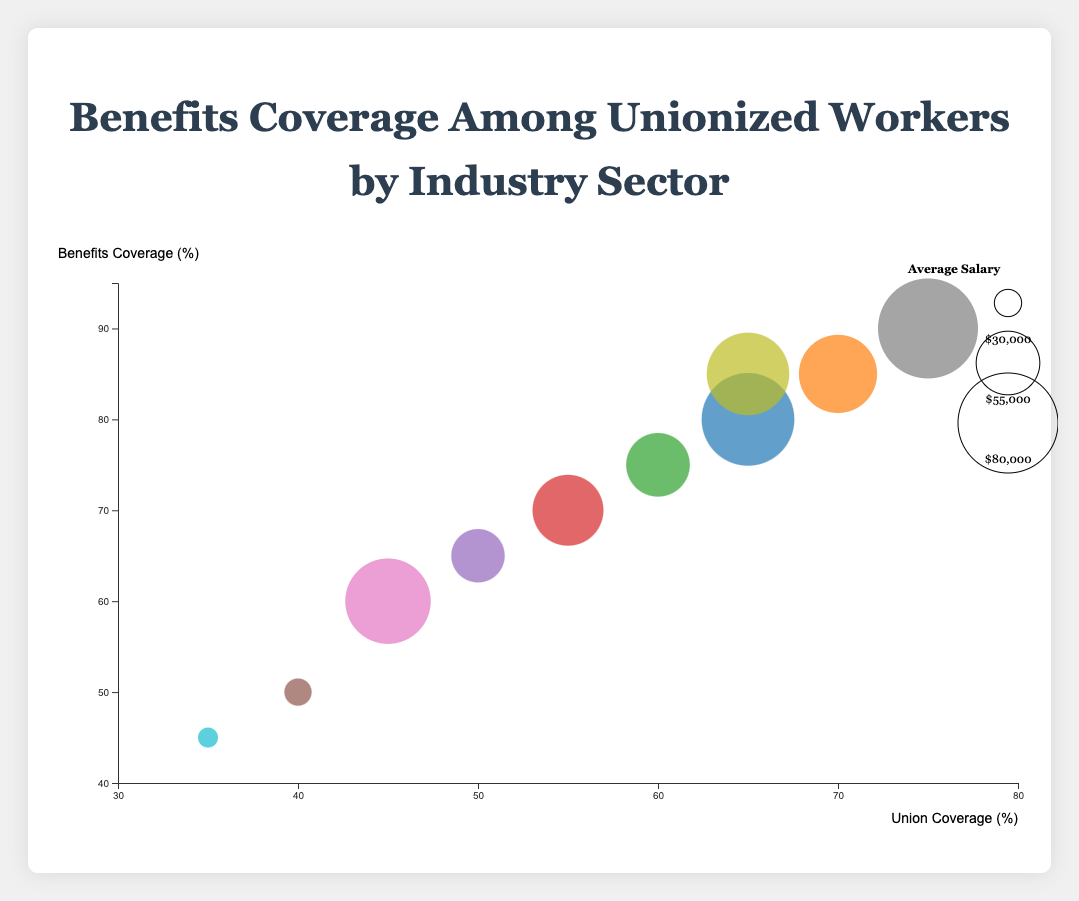What is the title of the chart? The title is usually placed at the top of the chart and provides a general description of the data being visualized. The title in bold, large text reads "Benefits Coverage Among Unionized Workers by Industry Sector".
Answer: Benefits Coverage Among Unionized Workers by Industry Sector Which industry has the highest union coverage percentage? To find the industry with the highest union coverage, look at the x-axis values and identify the bubble positioned farthest to the right. The "Public Administration" bubble is located at 75%.
Answer: Public Administration What is the average salary in the Healthcare sector? Locate the bubble labeled "Healthcare". The tooltip or the detailed description shows that the average salary for the Healthcare sector is $75,000.
Answer: $75,000 What is the size of the bubble representing the Education sector? The tooltips include information about each bubble's respective industry. Look at the "Education" bubble and observe the radius or refer to the tooltip that indicates an average salary of $65,000. The size scale from $30,000 to $80,000 suggests an intermediate-size bubble.
Answer: 65000 Which sector has the lowest benefits coverage percentage, and what percentage is it? Examine the y-axis values and identify the bubble positioned the lowest. The "Hospitality" bubble is at the 45% mark.
Answer: Hospitality, 45% Compare the union coverage percentages of Retail and Telecommunications sectors. Which one has a higher percentage? Identify the positions of the Retail and Telecommunications bubbles along the x-axis. Retail has a union coverage of 40%, while Telecommunications has 45%. So, Telecommunications has a higher percentage.
Answer: Telecommunications What is the difference in benefits coverage percentages between Education and Manufacturing sectors? Find the benefits coverage percentages for Education and Manufacturing sectors by looking at their positions along the y-axis. Education is at 85%, and Manufacturing is at 75%. Subtract 75 from 85, resulting in a 10% difference.
Answer: 10% Which sector has the largest bubble and what is its average salary? The largest bubble usually corresponds to the highest average salary. According to the chart, "Public Administration" has the largest bubble with an average salary of $80,000.
Answer: Public Administration, $80,000 What can you infer about the relationship between union coverage and benefits coverage when comparing the Healthcare and Retail sectors? Look at the positions of the Healthcare and Retail sectors on both axes. Healthcare has higher percentages on both axes (65% union coverage and 80% benefits coverage) compared to Retail (40% union coverage and 50% benefits coverage). This suggests that higher union coverage might correspond to higher benefits coverage.
Answer: Higher union coverage may correlate with higher benefits coverage How does the average salary in the Construction sector compare to that in the Telecommunications sector? Check the respective bubbles for Construction and Telecommunications sectors. Construction has an average salary of $60,000, while Telecommunications has $70,000. The Telecommunications sector has a higher average salary.
Answer: Telecommunications sector has a higher average salary 